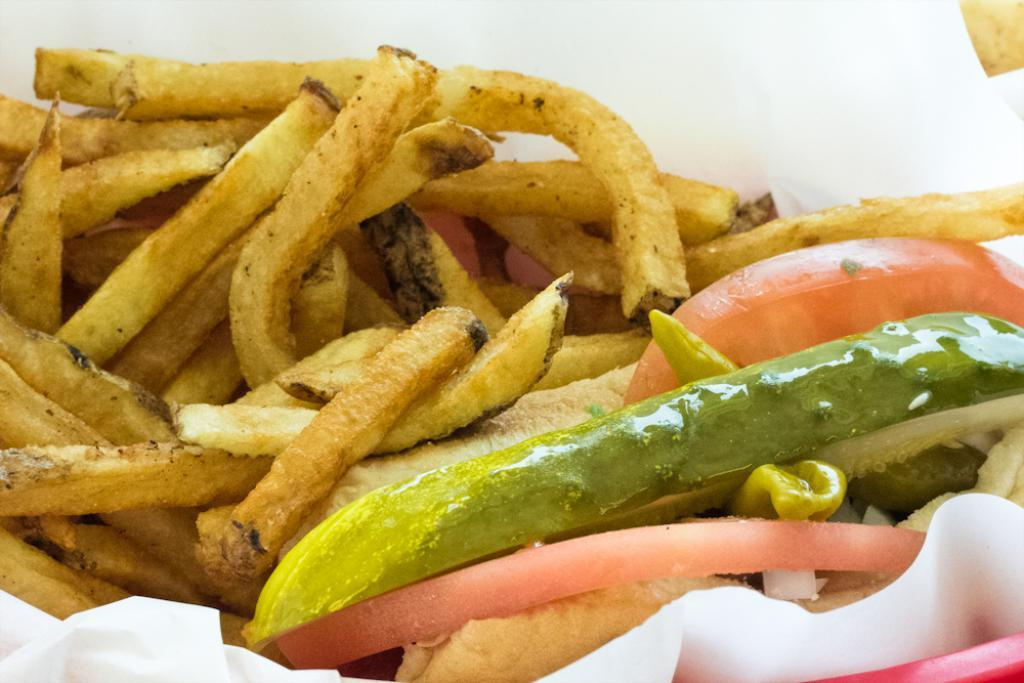What type of food can be seen in the foreground of the image? There are french fries, chilli, and tomato pieces in the foreground of the image. What is used for cleaning or wiping in the foreground of the image? There is tissue paper in the foreground of the image. What color is the red object in the foreground of the image? The red object in the foreground of the image is not described in the facts, so we cannot determine its color. What type of bean is present in the image? There is no bean mentioned or visible in the image. What type of metal is used to make the utensils in the image? There is no mention of utensils or metal in the image. 